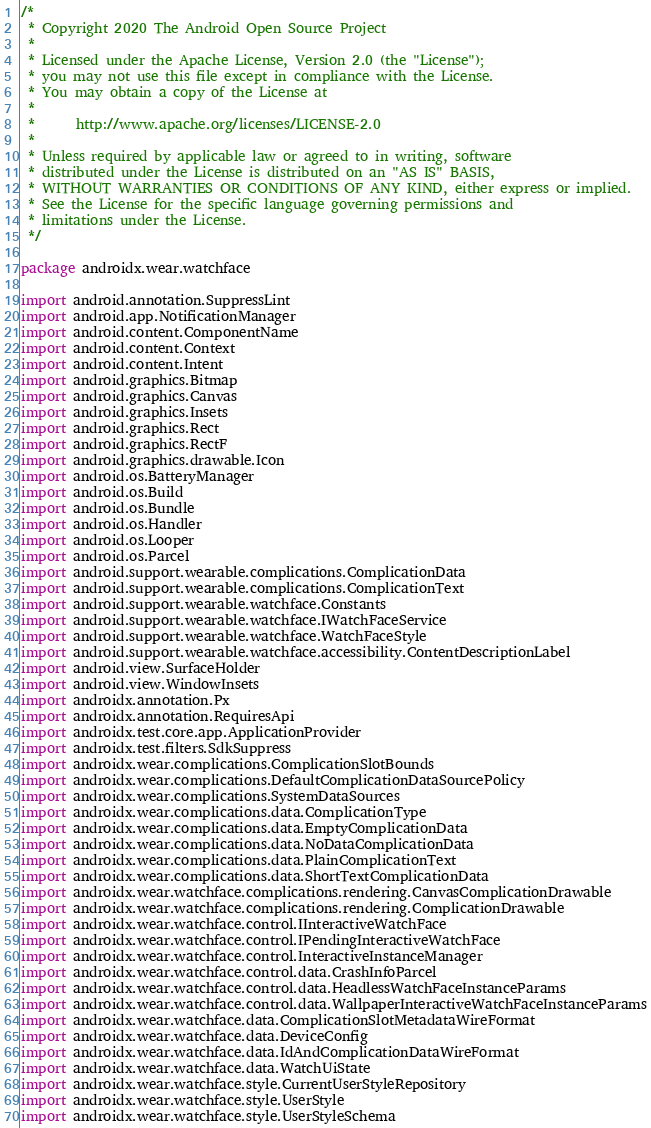Convert code to text. <code><loc_0><loc_0><loc_500><loc_500><_Kotlin_>/*
 * Copyright 2020 The Android Open Source Project
 *
 * Licensed under the Apache License, Version 2.0 (the "License");
 * you may not use this file except in compliance with the License.
 * You may obtain a copy of the License at
 *
 *      http://www.apache.org/licenses/LICENSE-2.0
 *
 * Unless required by applicable law or agreed to in writing, software
 * distributed under the License is distributed on an "AS IS" BASIS,
 * WITHOUT WARRANTIES OR CONDITIONS OF ANY KIND, either express or implied.
 * See the License for the specific language governing permissions and
 * limitations under the License.
 */

package androidx.wear.watchface

import android.annotation.SuppressLint
import android.app.NotificationManager
import android.content.ComponentName
import android.content.Context
import android.content.Intent
import android.graphics.Bitmap
import android.graphics.Canvas
import android.graphics.Insets
import android.graphics.Rect
import android.graphics.RectF
import android.graphics.drawable.Icon
import android.os.BatteryManager
import android.os.Build
import android.os.Bundle
import android.os.Handler
import android.os.Looper
import android.os.Parcel
import android.support.wearable.complications.ComplicationData
import android.support.wearable.complications.ComplicationText
import android.support.wearable.watchface.Constants
import android.support.wearable.watchface.IWatchFaceService
import android.support.wearable.watchface.WatchFaceStyle
import android.support.wearable.watchface.accessibility.ContentDescriptionLabel
import android.view.SurfaceHolder
import android.view.WindowInsets
import androidx.annotation.Px
import androidx.annotation.RequiresApi
import androidx.test.core.app.ApplicationProvider
import androidx.test.filters.SdkSuppress
import androidx.wear.complications.ComplicationSlotBounds
import androidx.wear.complications.DefaultComplicationDataSourcePolicy
import androidx.wear.complications.SystemDataSources
import androidx.wear.complications.data.ComplicationType
import androidx.wear.complications.data.EmptyComplicationData
import androidx.wear.complications.data.NoDataComplicationData
import androidx.wear.complications.data.PlainComplicationText
import androidx.wear.complications.data.ShortTextComplicationData
import androidx.wear.watchface.complications.rendering.CanvasComplicationDrawable
import androidx.wear.watchface.complications.rendering.ComplicationDrawable
import androidx.wear.watchface.control.IInteractiveWatchFace
import androidx.wear.watchface.control.IPendingInteractiveWatchFace
import androidx.wear.watchface.control.InteractiveInstanceManager
import androidx.wear.watchface.control.data.CrashInfoParcel
import androidx.wear.watchface.control.data.HeadlessWatchFaceInstanceParams
import androidx.wear.watchface.control.data.WallpaperInteractiveWatchFaceInstanceParams
import androidx.wear.watchface.data.ComplicationSlotMetadataWireFormat
import androidx.wear.watchface.data.DeviceConfig
import androidx.wear.watchface.data.IdAndComplicationDataWireFormat
import androidx.wear.watchface.data.WatchUiState
import androidx.wear.watchface.style.CurrentUserStyleRepository
import androidx.wear.watchface.style.UserStyle
import androidx.wear.watchface.style.UserStyleSchema</code> 